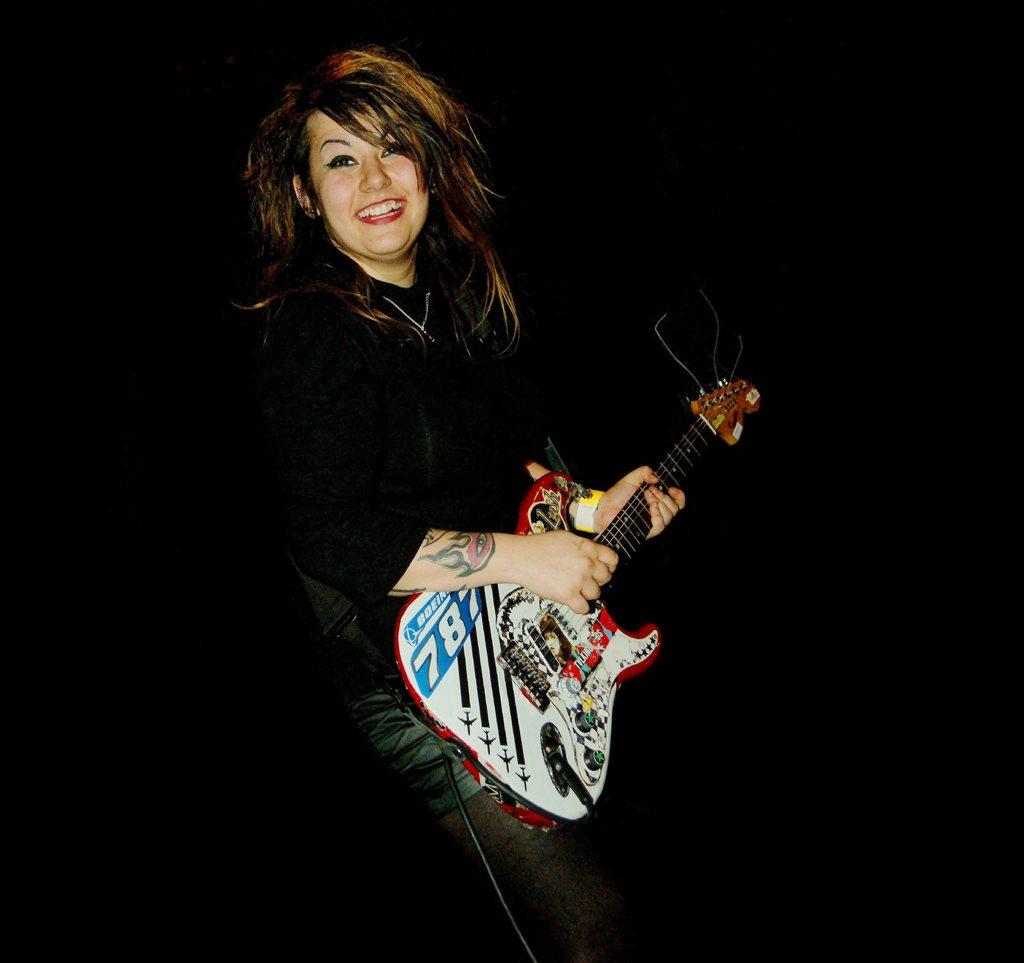What is the main subject of the picture? The main subject of the picture is a woman. What is the woman doing in the picture? The woman is standing and playing a guitar. What is the woman's facial expression in the picture? The woman is smiling in the picture. What type of army uniform is the woman wearing in the image? There is no army uniform present in the image; the woman is wearing casual clothing while playing the guitar. Can you recite the verse that the woman is singing in the image? There is no indication that the woman is singing in the image, and no lyrics are visible or audible. 